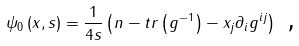Convert formula to latex. <formula><loc_0><loc_0><loc_500><loc_500>\psi _ { 0 } \left ( x , s \right ) = \frac { 1 } { 4 s } \left ( n - t r \left ( g ^ { - 1 } \right ) - x _ { j } \partial _ { i } g ^ { i j } \right ) \text { ,}</formula> 